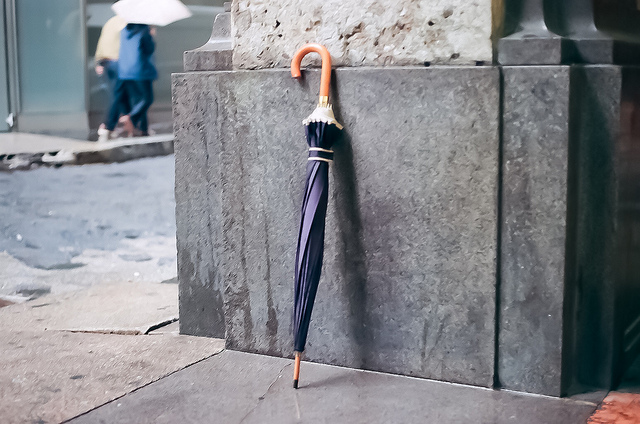What can you tell me about the location of the image? The image showcases an urban environment. We can notice buildings and paved sidewalks, which typically characterize a city setting. Can you guess which city this might be? Without distinct landmarks or geographic indicators, I cannot accurately determine the city depicted in the image. 